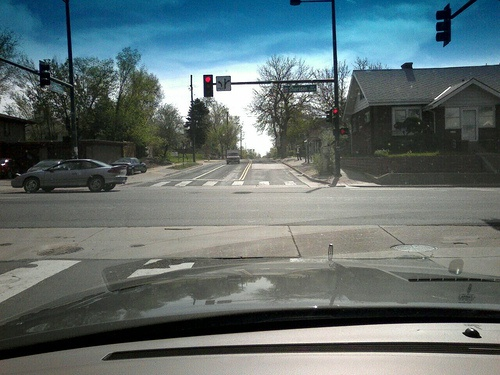Describe the objects in this image and their specific colors. I can see car in blue, gray, black, darkgray, and lightgray tones, car in blue, black, and purple tones, traffic light in blue, black, navy, and teal tones, car in blue, gray, black, and purple tones, and traffic light in blue, black, white, darkgray, and gray tones in this image. 